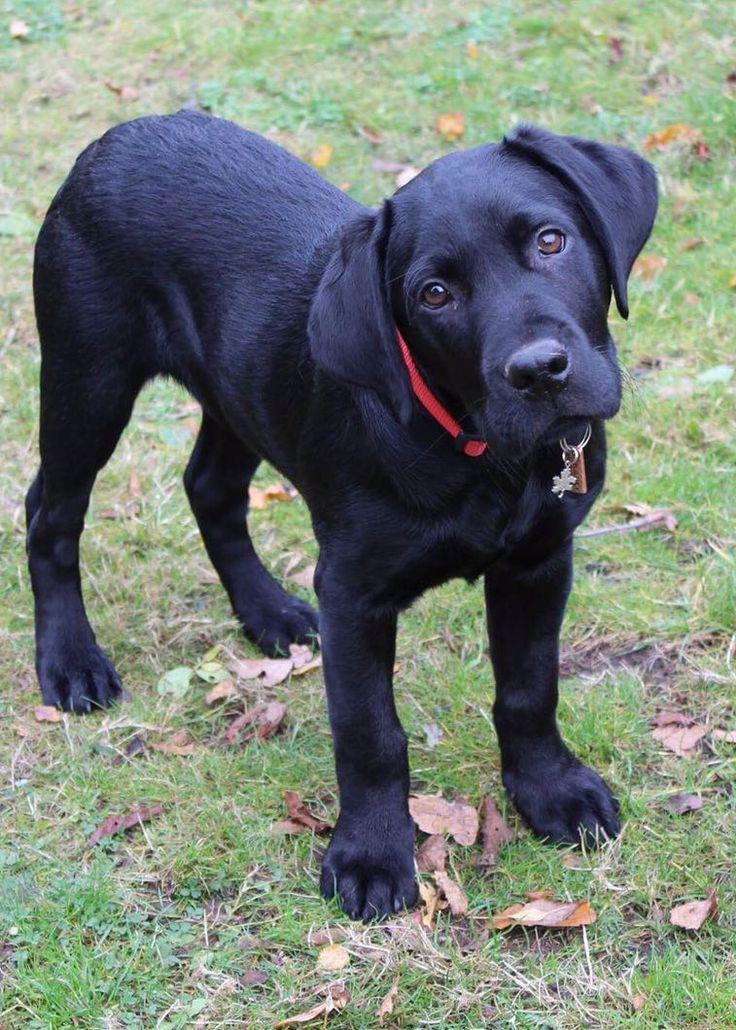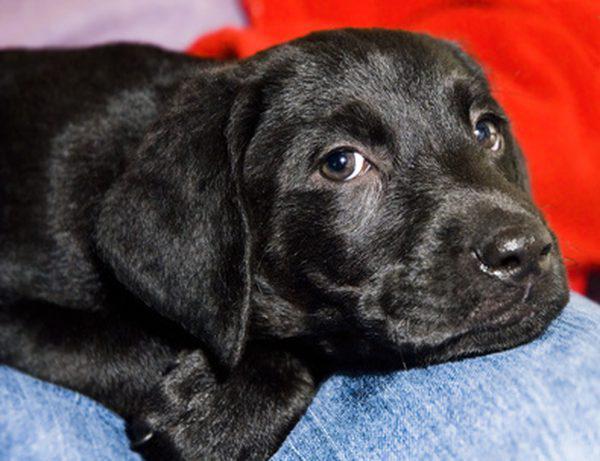The first image is the image on the left, the second image is the image on the right. Analyze the images presented: Is the assertion "there is a puppy with tags on it's collar" valid? Answer yes or no. Yes. 